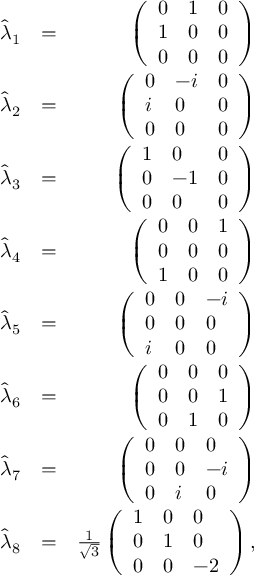Convert formula to latex. <formula><loc_0><loc_0><loc_500><loc_500>\begin{array} { r l r } { \hat { \lambda } _ { 1 } } & { = } & { \left ( \begin{array} { l l l } { 0 } & { 1 } & { 0 } \\ { 1 } & { 0 } & { 0 } \\ { 0 } & { 0 } & { 0 } \end{array} \right ) } \\ { \hat { \lambda } _ { 2 } } & { = } & { \left ( \begin{array} { l l l } { 0 } & { - i } & { 0 } \\ { i } & { 0 } & { 0 } \\ { 0 } & { 0 } & { 0 } \end{array} \right ) } \\ { \hat { \lambda } _ { 3 } } & { = } & { \left ( \begin{array} { l l l } { 1 } & { 0 } & { 0 } \\ { 0 } & { - 1 } & { 0 } \\ { 0 } & { 0 } & { 0 } \end{array} \right ) } \\ { \hat { \lambda } _ { 4 } } & { = } & { \left ( \begin{array} { l l l } { 0 } & { 0 } & { 1 } \\ { 0 } & { 0 } & { 0 } \\ { 1 } & { 0 } & { 0 } \end{array} \right ) } \\ { \hat { \lambda } _ { 5 } } & { = } & { \left ( \begin{array} { l l l } { 0 } & { 0 } & { - i } \\ { 0 } & { 0 } & { 0 } \\ { i } & { 0 } & { 0 } \end{array} \right ) } \\ { \hat { \lambda } _ { 6 } } & { = } & { \left ( \begin{array} { l l l } { 0 } & { 0 } & { 0 } \\ { 0 } & { 0 } & { 1 } \\ { 0 } & { 1 } & { 0 } \end{array} \right ) } \\ { \hat { \lambda } _ { 7 } } & { = } & { \left ( \begin{array} { l l l } { 0 } & { 0 } & { 0 } \\ { 0 } & { 0 } & { - i } \\ { 0 } & { i } & { 0 } \end{array} \right ) } \\ { \hat { \lambda } _ { 8 } } & { = } & { \frac { 1 } { \sqrt { 3 } } \left ( \begin{array} { l l l } { 1 } & { 0 } & { 0 } \\ { 0 } & { 1 } & { 0 } \\ { 0 } & { 0 } & { - 2 } \end{array} \right ) , } \end{array}</formula> 